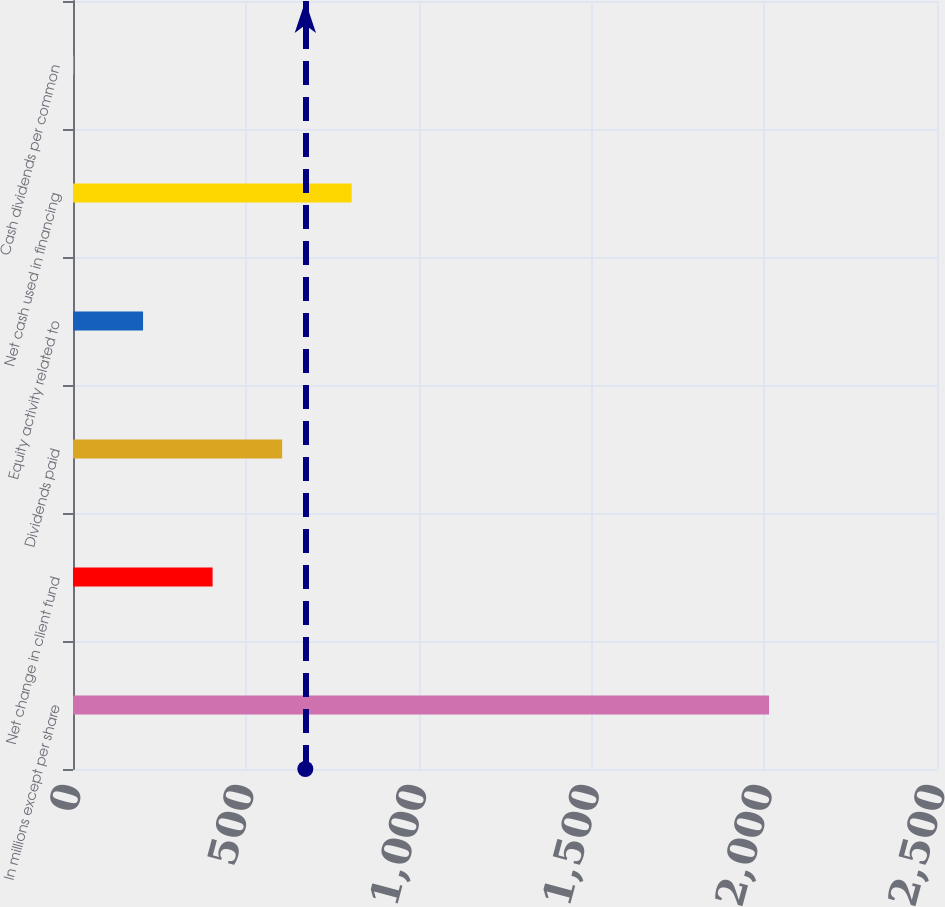Convert chart to OTSL. <chart><loc_0><loc_0><loc_500><loc_500><bar_chart><fcel>In millions except per share<fcel>Net change in client fund<fcel>Dividends paid<fcel>Equity activity related to<fcel>Net cash used in financing<fcel>Cash dividends per common<nl><fcel>2014<fcel>403.92<fcel>605.18<fcel>202.66<fcel>806.44<fcel>1.4<nl></chart> 